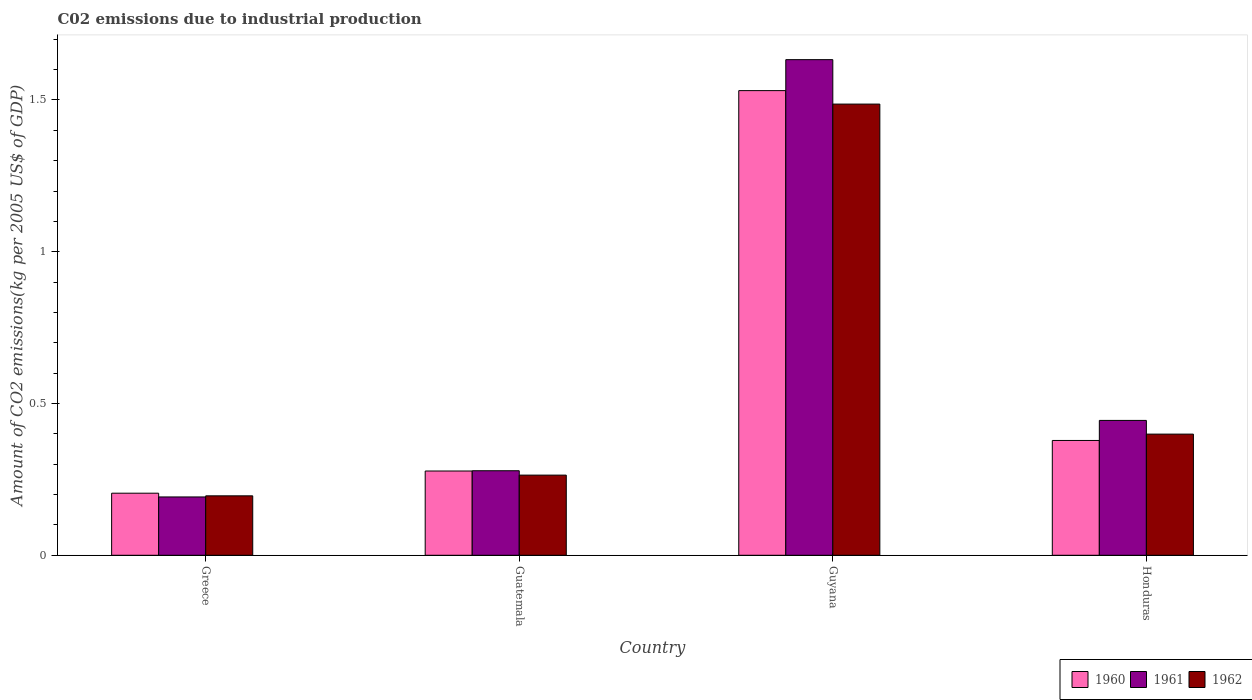How many different coloured bars are there?
Ensure brevity in your answer.  3. Are the number of bars per tick equal to the number of legend labels?
Give a very brief answer. Yes. Are the number of bars on each tick of the X-axis equal?
Your response must be concise. Yes. How many bars are there on the 2nd tick from the left?
Give a very brief answer. 3. What is the label of the 2nd group of bars from the left?
Your answer should be compact. Guatemala. In how many cases, is the number of bars for a given country not equal to the number of legend labels?
Give a very brief answer. 0. What is the amount of CO2 emitted due to industrial production in 1960 in Honduras?
Give a very brief answer. 0.38. Across all countries, what is the maximum amount of CO2 emitted due to industrial production in 1960?
Provide a short and direct response. 1.53. Across all countries, what is the minimum amount of CO2 emitted due to industrial production in 1962?
Offer a very short reply. 0.2. In which country was the amount of CO2 emitted due to industrial production in 1962 maximum?
Your response must be concise. Guyana. What is the total amount of CO2 emitted due to industrial production in 1962 in the graph?
Offer a very short reply. 2.35. What is the difference between the amount of CO2 emitted due to industrial production in 1961 in Greece and that in Guyana?
Your answer should be very brief. -1.44. What is the difference between the amount of CO2 emitted due to industrial production in 1960 in Guatemala and the amount of CO2 emitted due to industrial production in 1962 in Honduras?
Your answer should be compact. -0.12. What is the average amount of CO2 emitted due to industrial production in 1961 per country?
Provide a short and direct response. 0.64. What is the difference between the amount of CO2 emitted due to industrial production of/in 1962 and amount of CO2 emitted due to industrial production of/in 1960 in Guatemala?
Provide a short and direct response. -0.01. What is the ratio of the amount of CO2 emitted due to industrial production in 1960 in Guatemala to that in Honduras?
Your answer should be very brief. 0.73. What is the difference between the highest and the second highest amount of CO2 emitted due to industrial production in 1961?
Your answer should be compact. -1.19. What is the difference between the highest and the lowest amount of CO2 emitted due to industrial production in 1961?
Make the answer very short. 1.44. Is the sum of the amount of CO2 emitted due to industrial production in 1961 in Greece and Guatemala greater than the maximum amount of CO2 emitted due to industrial production in 1962 across all countries?
Provide a succinct answer. No. What does the 2nd bar from the left in Greece represents?
Keep it short and to the point. 1961. What does the 3rd bar from the right in Guyana represents?
Give a very brief answer. 1960. Is it the case that in every country, the sum of the amount of CO2 emitted due to industrial production in 1962 and amount of CO2 emitted due to industrial production in 1961 is greater than the amount of CO2 emitted due to industrial production in 1960?
Offer a very short reply. Yes. How many countries are there in the graph?
Keep it short and to the point. 4. Are the values on the major ticks of Y-axis written in scientific E-notation?
Your response must be concise. No. Does the graph contain any zero values?
Your answer should be compact. No. Does the graph contain grids?
Your answer should be very brief. No. Where does the legend appear in the graph?
Your response must be concise. Bottom right. What is the title of the graph?
Your answer should be compact. C02 emissions due to industrial production. What is the label or title of the Y-axis?
Give a very brief answer. Amount of CO2 emissions(kg per 2005 US$ of GDP). What is the Amount of CO2 emissions(kg per 2005 US$ of GDP) of 1960 in Greece?
Ensure brevity in your answer.  0.2. What is the Amount of CO2 emissions(kg per 2005 US$ of GDP) in 1961 in Greece?
Offer a very short reply. 0.19. What is the Amount of CO2 emissions(kg per 2005 US$ of GDP) in 1962 in Greece?
Offer a terse response. 0.2. What is the Amount of CO2 emissions(kg per 2005 US$ of GDP) in 1960 in Guatemala?
Your answer should be compact. 0.28. What is the Amount of CO2 emissions(kg per 2005 US$ of GDP) of 1961 in Guatemala?
Make the answer very short. 0.28. What is the Amount of CO2 emissions(kg per 2005 US$ of GDP) of 1962 in Guatemala?
Ensure brevity in your answer.  0.26. What is the Amount of CO2 emissions(kg per 2005 US$ of GDP) in 1960 in Guyana?
Offer a terse response. 1.53. What is the Amount of CO2 emissions(kg per 2005 US$ of GDP) in 1961 in Guyana?
Offer a very short reply. 1.63. What is the Amount of CO2 emissions(kg per 2005 US$ of GDP) in 1962 in Guyana?
Provide a short and direct response. 1.49. What is the Amount of CO2 emissions(kg per 2005 US$ of GDP) of 1960 in Honduras?
Ensure brevity in your answer.  0.38. What is the Amount of CO2 emissions(kg per 2005 US$ of GDP) in 1961 in Honduras?
Ensure brevity in your answer.  0.44. What is the Amount of CO2 emissions(kg per 2005 US$ of GDP) of 1962 in Honduras?
Keep it short and to the point. 0.4. Across all countries, what is the maximum Amount of CO2 emissions(kg per 2005 US$ of GDP) in 1960?
Provide a short and direct response. 1.53. Across all countries, what is the maximum Amount of CO2 emissions(kg per 2005 US$ of GDP) in 1961?
Your answer should be very brief. 1.63. Across all countries, what is the maximum Amount of CO2 emissions(kg per 2005 US$ of GDP) of 1962?
Provide a succinct answer. 1.49. Across all countries, what is the minimum Amount of CO2 emissions(kg per 2005 US$ of GDP) of 1960?
Your answer should be very brief. 0.2. Across all countries, what is the minimum Amount of CO2 emissions(kg per 2005 US$ of GDP) in 1961?
Offer a very short reply. 0.19. Across all countries, what is the minimum Amount of CO2 emissions(kg per 2005 US$ of GDP) of 1962?
Provide a short and direct response. 0.2. What is the total Amount of CO2 emissions(kg per 2005 US$ of GDP) of 1960 in the graph?
Offer a very short reply. 2.39. What is the total Amount of CO2 emissions(kg per 2005 US$ of GDP) of 1961 in the graph?
Offer a terse response. 2.55. What is the total Amount of CO2 emissions(kg per 2005 US$ of GDP) of 1962 in the graph?
Provide a short and direct response. 2.35. What is the difference between the Amount of CO2 emissions(kg per 2005 US$ of GDP) of 1960 in Greece and that in Guatemala?
Keep it short and to the point. -0.07. What is the difference between the Amount of CO2 emissions(kg per 2005 US$ of GDP) of 1961 in Greece and that in Guatemala?
Your answer should be very brief. -0.09. What is the difference between the Amount of CO2 emissions(kg per 2005 US$ of GDP) of 1962 in Greece and that in Guatemala?
Keep it short and to the point. -0.07. What is the difference between the Amount of CO2 emissions(kg per 2005 US$ of GDP) in 1960 in Greece and that in Guyana?
Offer a terse response. -1.33. What is the difference between the Amount of CO2 emissions(kg per 2005 US$ of GDP) in 1961 in Greece and that in Guyana?
Offer a very short reply. -1.44. What is the difference between the Amount of CO2 emissions(kg per 2005 US$ of GDP) in 1962 in Greece and that in Guyana?
Provide a succinct answer. -1.29. What is the difference between the Amount of CO2 emissions(kg per 2005 US$ of GDP) in 1960 in Greece and that in Honduras?
Your answer should be very brief. -0.17. What is the difference between the Amount of CO2 emissions(kg per 2005 US$ of GDP) of 1961 in Greece and that in Honduras?
Provide a succinct answer. -0.25. What is the difference between the Amount of CO2 emissions(kg per 2005 US$ of GDP) of 1962 in Greece and that in Honduras?
Your response must be concise. -0.2. What is the difference between the Amount of CO2 emissions(kg per 2005 US$ of GDP) in 1960 in Guatemala and that in Guyana?
Provide a succinct answer. -1.25. What is the difference between the Amount of CO2 emissions(kg per 2005 US$ of GDP) of 1961 in Guatemala and that in Guyana?
Your response must be concise. -1.35. What is the difference between the Amount of CO2 emissions(kg per 2005 US$ of GDP) in 1962 in Guatemala and that in Guyana?
Ensure brevity in your answer.  -1.22. What is the difference between the Amount of CO2 emissions(kg per 2005 US$ of GDP) of 1960 in Guatemala and that in Honduras?
Your answer should be very brief. -0.1. What is the difference between the Amount of CO2 emissions(kg per 2005 US$ of GDP) in 1961 in Guatemala and that in Honduras?
Offer a terse response. -0.17. What is the difference between the Amount of CO2 emissions(kg per 2005 US$ of GDP) in 1962 in Guatemala and that in Honduras?
Your answer should be compact. -0.14. What is the difference between the Amount of CO2 emissions(kg per 2005 US$ of GDP) in 1960 in Guyana and that in Honduras?
Offer a terse response. 1.15. What is the difference between the Amount of CO2 emissions(kg per 2005 US$ of GDP) of 1961 in Guyana and that in Honduras?
Your response must be concise. 1.19. What is the difference between the Amount of CO2 emissions(kg per 2005 US$ of GDP) in 1962 in Guyana and that in Honduras?
Offer a terse response. 1.09. What is the difference between the Amount of CO2 emissions(kg per 2005 US$ of GDP) in 1960 in Greece and the Amount of CO2 emissions(kg per 2005 US$ of GDP) in 1961 in Guatemala?
Give a very brief answer. -0.07. What is the difference between the Amount of CO2 emissions(kg per 2005 US$ of GDP) in 1960 in Greece and the Amount of CO2 emissions(kg per 2005 US$ of GDP) in 1962 in Guatemala?
Your answer should be compact. -0.06. What is the difference between the Amount of CO2 emissions(kg per 2005 US$ of GDP) of 1961 in Greece and the Amount of CO2 emissions(kg per 2005 US$ of GDP) of 1962 in Guatemala?
Offer a terse response. -0.07. What is the difference between the Amount of CO2 emissions(kg per 2005 US$ of GDP) of 1960 in Greece and the Amount of CO2 emissions(kg per 2005 US$ of GDP) of 1961 in Guyana?
Provide a short and direct response. -1.43. What is the difference between the Amount of CO2 emissions(kg per 2005 US$ of GDP) of 1960 in Greece and the Amount of CO2 emissions(kg per 2005 US$ of GDP) of 1962 in Guyana?
Your answer should be very brief. -1.28. What is the difference between the Amount of CO2 emissions(kg per 2005 US$ of GDP) of 1961 in Greece and the Amount of CO2 emissions(kg per 2005 US$ of GDP) of 1962 in Guyana?
Make the answer very short. -1.29. What is the difference between the Amount of CO2 emissions(kg per 2005 US$ of GDP) of 1960 in Greece and the Amount of CO2 emissions(kg per 2005 US$ of GDP) of 1961 in Honduras?
Keep it short and to the point. -0.24. What is the difference between the Amount of CO2 emissions(kg per 2005 US$ of GDP) of 1960 in Greece and the Amount of CO2 emissions(kg per 2005 US$ of GDP) of 1962 in Honduras?
Provide a short and direct response. -0.19. What is the difference between the Amount of CO2 emissions(kg per 2005 US$ of GDP) of 1961 in Greece and the Amount of CO2 emissions(kg per 2005 US$ of GDP) of 1962 in Honduras?
Keep it short and to the point. -0.21. What is the difference between the Amount of CO2 emissions(kg per 2005 US$ of GDP) in 1960 in Guatemala and the Amount of CO2 emissions(kg per 2005 US$ of GDP) in 1961 in Guyana?
Give a very brief answer. -1.36. What is the difference between the Amount of CO2 emissions(kg per 2005 US$ of GDP) in 1960 in Guatemala and the Amount of CO2 emissions(kg per 2005 US$ of GDP) in 1962 in Guyana?
Make the answer very short. -1.21. What is the difference between the Amount of CO2 emissions(kg per 2005 US$ of GDP) in 1961 in Guatemala and the Amount of CO2 emissions(kg per 2005 US$ of GDP) in 1962 in Guyana?
Ensure brevity in your answer.  -1.21. What is the difference between the Amount of CO2 emissions(kg per 2005 US$ of GDP) in 1960 in Guatemala and the Amount of CO2 emissions(kg per 2005 US$ of GDP) in 1962 in Honduras?
Provide a succinct answer. -0.12. What is the difference between the Amount of CO2 emissions(kg per 2005 US$ of GDP) of 1961 in Guatemala and the Amount of CO2 emissions(kg per 2005 US$ of GDP) of 1962 in Honduras?
Offer a very short reply. -0.12. What is the difference between the Amount of CO2 emissions(kg per 2005 US$ of GDP) of 1960 in Guyana and the Amount of CO2 emissions(kg per 2005 US$ of GDP) of 1961 in Honduras?
Your answer should be very brief. 1.09. What is the difference between the Amount of CO2 emissions(kg per 2005 US$ of GDP) of 1960 in Guyana and the Amount of CO2 emissions(kg per 2005 US$ of GDP) of 1962 in Honduras?
Your response must be concise. 1.13. What is the difference between the Amount of CO2 emissions(kg per 2005 US$ of GDP) in 1961 in Guyana and the Amount of CO2 emissions(kg per 2005 US$ of GDP) in 1962 in Honduras?
Your answer should be compact. 1.23. What is the average Amount of CO2 emissions(kg per 2005 US$ of GDP) of 1960 per country?
Provide a succinct answer. 0.6. What is the average Amount of CO2 emissions(kg per 2005 US$ of GDP) of 1961 per country?
Provide a succinct answer. 0.64. What is the average Amount of CO2 emissions(kg per 2005 US$ of GDP) in 1962 per country?
Give a very brief answer. 0.59. What is the difference between the Amount of CO2 emissions(kg per 2005 US$ of GDP) of 1960 and Amount of CO2 emissions(kg per 2005 US$ of GDP) of 1961 in Greece?
Your answer should be very brief. 0.01. What is the difference between the Amount of CO2 emissions(kg per 2005 US$ of GDP) of 1960 and Amount of CO2 emissions(kg per 2005 US$ of GDP) of 1962 in Greece?
Provide a short and direct response. 0.01. What is the difference between the Amount of CO2 emissions(kg per 2005 US$ of GDP) of 1961 and Amount of CO2 emissions(kg per 2005 US$ of GDP) of 1962 in Greece?
Keep it short and to the point. -0. What is the difference between the Amount of CO2 emissions(kg per 2005 US$ of GDP) in 1960 and Amount of CO2 emissions(kg per 2005 US$ of GDP) in 1961 in Guatemala?
Offer a terse response. -0. What is the difference between the Amount of CO2 emissions(kg per 2005 US$ of GDP) in 1960 and Amount of CO2 emissions(kg per 2005 US$ of GDP) in 1962 in Guatemala?
Your answer should be compact. 0.01. What is the difference between the Amount of CO2 emissions(kg per 2005 US$ of GDP) in 1961 and Amount of CO2 emissions(kg per 2005 US$ of GDP) in 1962 in Guatemala?
Keep it short and to the point. 0.01. What is the difference between the Amount of CO2 emissions(kg per 2005 US$ of GDP) in 1960 and Amount of CO2 emissions(kg per 2005 US$ of GDP) in 1961 in Guyana?
Provide a succinct answer. -0.1. What is the difference between the Amount of CO2 emissions(kg per 2005 US$ of GDP) in 1960 and Amount of CO2 emissions(kg per 2005 US$ of GDP) in 1962 in Guyana?
Provide a succinct answer. 0.04. What is the difference between the Amount of CO2 emissions(kg per 2005 US$ of GDP) of 1961 and Amount of CO2 emissions(kg per 2005 US$ of GDP) of 1962 in Guyana?
Give a very brief answer. 0.15. What is the difference between the Amount of CO2 emissions(kg per 2005 US$ of GDP) in 1960 and Amount of CO2 emissions(kg per 2005 US$ of GDP) in 1961 in Honduras?
Provide a succinct answer. -0.07. What is the difference between the Amount of CO2 emissions(kg per 2005 US$ of GDP) in 1960 and Amount of CO2 emissions(kg per 2005 US$ of GDP) in 1962 in Honduras?
Your answer should be very brief. -0.02. What is the difference between the Amount of CO2 emissions(kg per 2005 US$ of GDP) of 1961 and Amount of CO2 emissions(kg per 2005 US$ of GDP) of 1962 in Honduras?
Offer a terse response. 0.05. What is the ratio of the Amount of CO2 emissions(kg per 2005 US$ of GDP) of 1960 in Greece to that in Guatemala?
Offer a terse response. 0.74. What is the ratio of the Amount of CO2 emissions(kg per 2005 US$ of GDP) in 1961 in Greece to that in Guatemala?
Your answer should be very brief. 0.69. What is the ratio of the Amount of CO2 emissions(kg per 2005 US$ of GDP) in 1962 in Greece to that in Guatemala?
Offer a very short reply. 0.74. What is the ratio of the Amount of CO2 emissions(kg per 2005 US$ of GDP) in 1960 in Greece to that in Guyana?
Your response must be concise. 0.13. What is the ratio of the Amount of CO2 emissions(kg per 2005 US$ of GDP) of 1961 in Greece to that in Guyana?
Make the answer very short. 0.12. What is the ratio of the Amount of CO2 emissions(kg per 2005 US$ of GDP) in 1962 in Greece to that in Guyana?
Offer a terse response. 0.13. What is the ratio of the Amount of CO2 emissions(kg per 2005 US$ of GDP) in 1960 in Greece to that in Honduras?
Give a very brief answer. 0.54. What is the ratio of the Amount of CO2 emissions(kg per 2005 US$ of GDP) of 1961 in Greece to that in Honduras?
Make the answer very short. 0.43. What is the ratio of the Amount of CO2 emissions(kg per 2005 US$ of GDP) in 1962 in Greece to that in Honduras?
Offer a very short reply. 0.49. What is the ratio of the Amount of CO2 emissions(kg per 2005 US$ of GDP) of 1960 in Guatemala to that in Guyana?
Keep it short and to the point. 0.18. What is the ratio of the Amount of CO2 emissions(kg per 2005 US$ of GDP) in 1961 in Guatemala to that in Guyana?
Your response must be concise. 0.17. What is the ratio of the Amount of CO2 emissions(kg per 2005 US$ of GDP) in 1962 in Guatemala to that in Guyana?
Your response must be concise. 0.18. What is the ratio of the Amount of CO2 emissions(kg per 2005 US$ of GDP) in 1960 in Guatemala to that in Honduras?
Your response must be concise. 0.73. What is the ratio of the Amount of CO2 emissions(kg per 2005 US$ of GDP) in 1961 in Guatemala to that in Honduras?
Give a very brief answer. 0.63. What is the ratio of the Amount of CO2 emissions(kg per 2005 US$ of GDP) of 1962 in Guatemala to that in Honduras?
Ensure brevity in your answer.  0.66. What is the ratio of the Amount of CO2 emissions(kg per 2005 US$ of GDP) of 1960 in Guyana to that in Honduras?
Give a very brief answer. 4.05. What is the ratio of the Amount of CO2 emissions(kg per 2005 US$ of GDP) of 1961 in Guyana to that in Honduras?
Your response must be concise. 3.68. What is the ratio of the Amount of CO2 emissions(kg per 2005 US$ of GDP) in 1962 in Guyana to that in Honduras?
Make the answer very short. 3.72. What is the difference between the highest and the second highest Amount of CO2 emissions(kg per 2005 US$ of GDP) of 1960?
Keep it short and to the point. 1.15. What is the difference between the highest and the second highest Amount of CO2 emissions(kg per 2005 US$ of GDP) of 1961?
Offer a terse response. 1.19. What is the difference between the highest and the second highest Amount of CO2 emissions(kg per 2005 US$ of GDP) of 1962?
Provide a short and direct response. 1.09. What is the difference between the highest and the lowest Amount of CO2 emissions(kg per 2005 US$ of GDP) of 1960?
Make the answer very short. 1.33. What is the difference between the highest and the lowest Amount of CO2 emissions(kg per 2005 US$ of GDP) in 1961?
Offer a terse response. 1.44. What is the difference between the highest and the lowest Amount of CO2 emissions(kg per 2005 US$ of GDP) in 1962?
Provide a short and direct response. 1.29. 